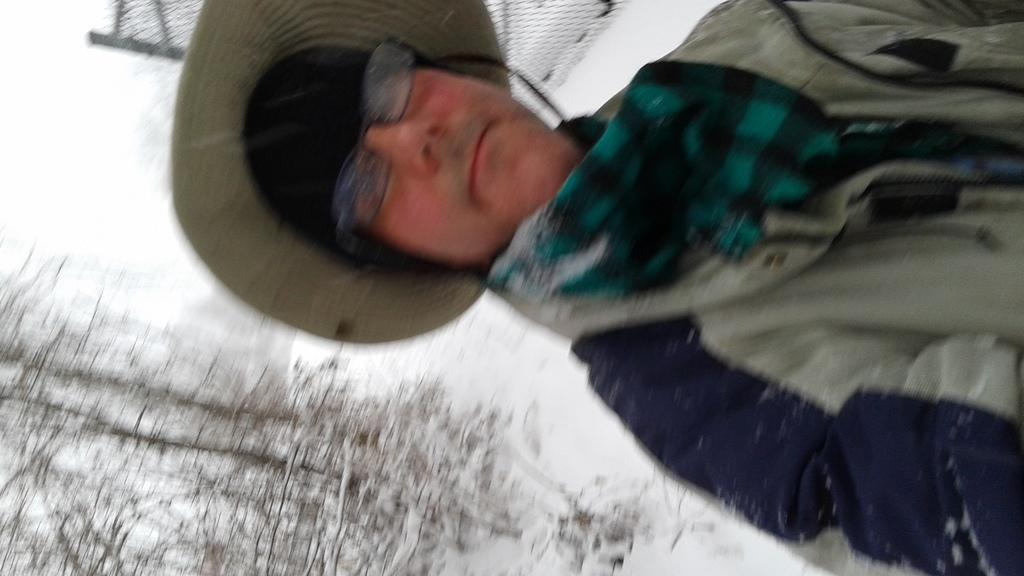Who or what is present in the image? There is a person in the image. What type of clothing is the person wearing? The person is wearing a jacket and a hat. What is the weather like in the image? There is snow visible in the image, indicating cold weather. What can be seen in the left bottom corner of the image? There are trees in the left bottom corner of the image. What type of flag is being waved by the person in the image? There is no flag present in the image; the person is not waving anything. How many hens can be seen in the image? There are no hens present in the image. 